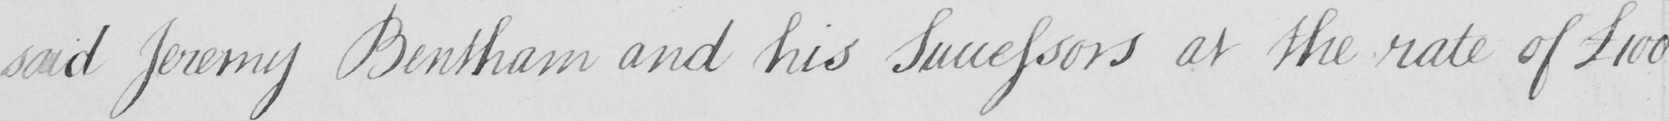Can you tell me what this handwritten text says? said Jeremy Bentham and his Successors at the rate of £100 